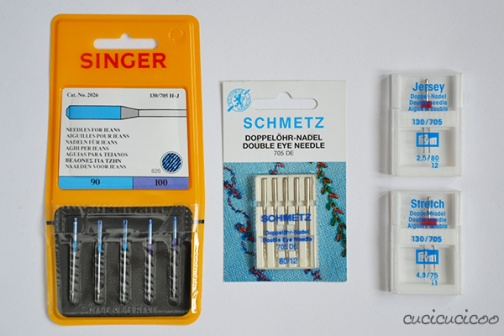What is this photo about? The photo displays an assortment of sewing needle packages from reputable brands, each suited for specific fabric types and sewing tasks. On the left is a vibrant yellow and orange Singer package featuring needles designed for knit fabrics. The center package from Schmetz includes double needles, which are particularly useful for tasks requiring parallel rows of stitching, such as hemming or decorative detailing. Lastly, the package on the right contains Stretch needles from Jersey, which are versatile for various fabric types including those with some elasticity. These needles differ not only in brand and needle sizes but also in their specialized uses, making them essential tools for tailor-made sewing projects. 